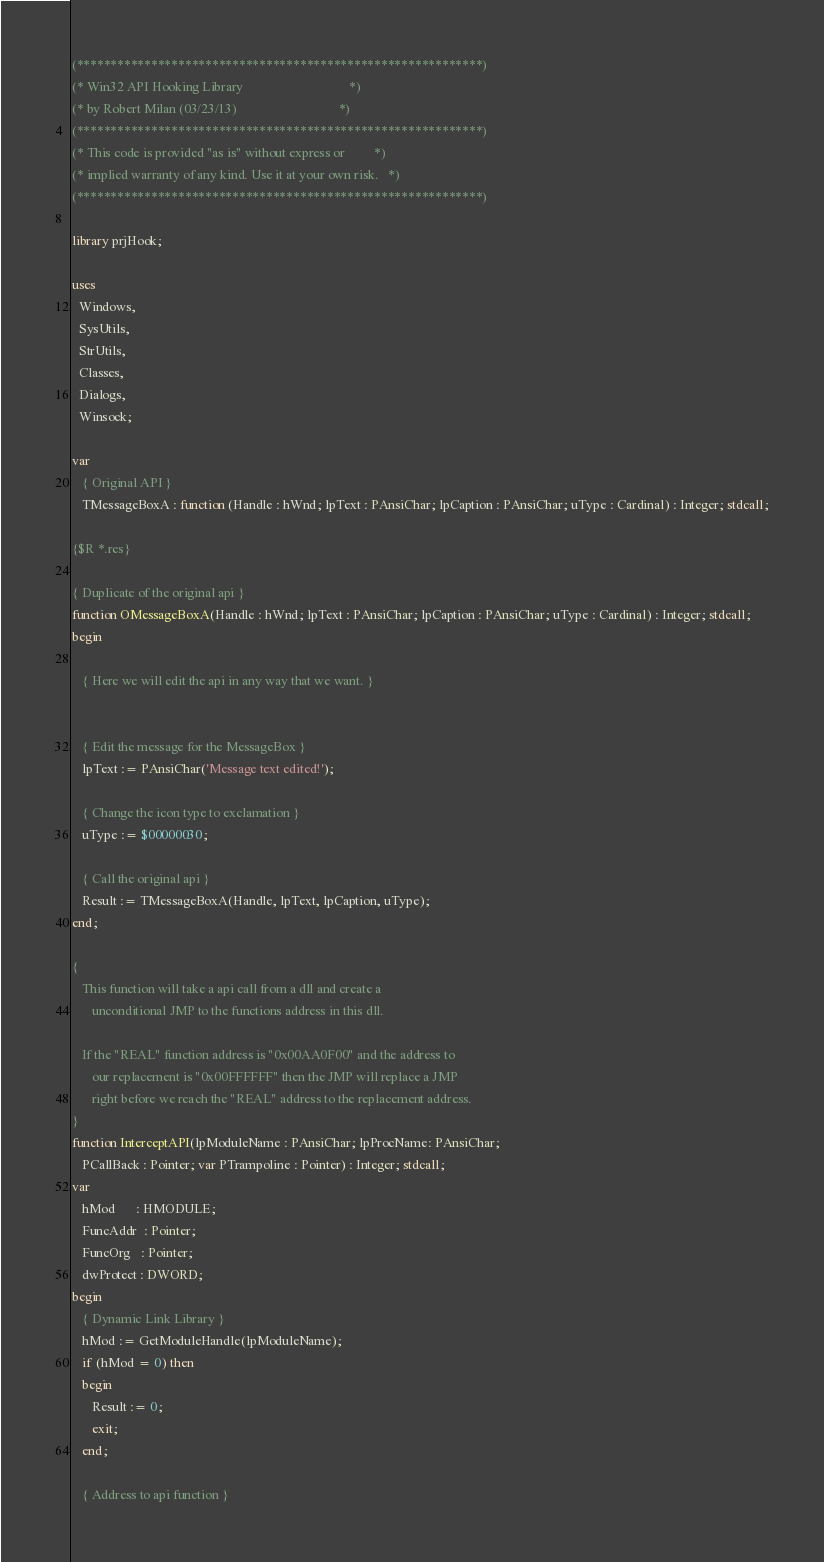<code> <loc_0><loc_0><loc_500><loc_500><_Pascal_>(************************************************************)
(* Win32 API Hooking Library                                *)
(* by Robert Milan (03/23/13)                               *)
(************************************************************)
(* This code is provided "as is" without express or         *)
(* implied warranty of any kind. Use it at your own risk.   *)
(************************************************************)

library prjHook;

uses
  Windows,
  SysUtils,
  StrUtils,
  Classes,
  Dialogs,
  Winsock;

var
   { Original API }
   TMessageBoxA : function (Handle : hWnd; lpText : PAnsiChar; lpCaption : PAnsiChar; uType : Cardinal) : Integer; stdcall;

{$R *.res}

{ Duplicate of the original api }
function OMessageBoxA(Handle : hWnd; lpText : PAnsiChar; lpCaption : PAnsiChar; uType : Cardinal) : Integer; stdcall;
begin

   { Here we will edit the api in any way that we want. }


   { Edit the message for the MessageBox }
   lpText := PAnsiChar('Message text edited!');

   { Change the icon type to exclamation }
   uType := $00000030;

   { Call the original api }
   Result := TMessageBoxA(Handle, lpText, lpCaption, uType);
end;

{
   This function will take a api call from a dll and create a
      unconditional JMP to the functions address in this dll.

   If the "REAL" function address is "0x00AA0F00" and the address to
      our replacement is "0x00FFFFFF" then the JMP will replace a JMP
      right before we reach the "REAL" address to the replacement address.
}
function InterceptAPI(lpModuleName : PAnsiChar; lpProcName: PAnsiChar;
   PCallBack : Pointer; var PTrampoline : Pointer) : Integer; stdcall;
var
   hMod      : HMODULE;
   FuncAddr  : Pointer;
   FuncOrg   : Pointer;
   dwProtect : DWORD;
begin
   { Dynamic Link Library }
   hMod := GetModuleHandle(lpModuleName);
   if (hMod = 0) then
   begin
      Result := 0;
      exit;
   end;

   { Address to api function }</code> 